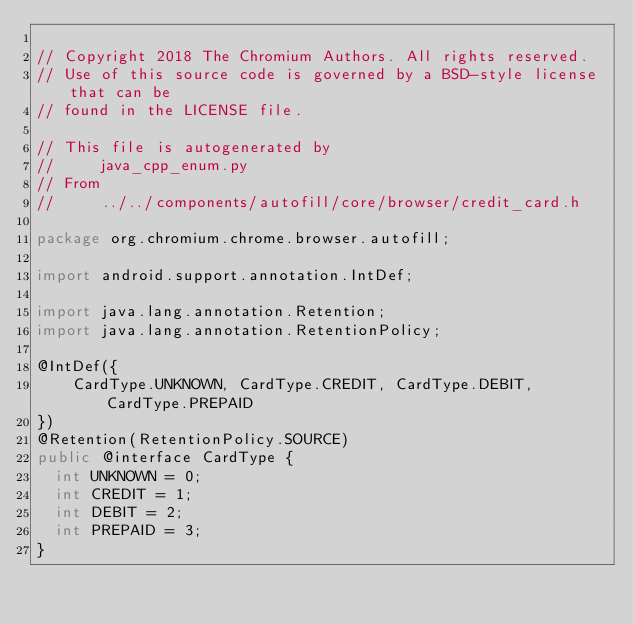<code> <loc_0><loc_0><loc_500><loc_500><_Java_>
// Copyright 2018 The Chromium Authors. All rights reserved.
// Use of this source code is governed by a BSD-style license that can be
// found in the LICENSE file.

// This file is autogenerated by
//     java_cpp_enum.py
// From
//     ../../components/autofill/core/browser/credit_card.h

package org.chromium.chrome.browser.autofill;

import android.support.annotation.IntDef;

import java.lang.annotation.Retention;
import java.lang.annotation.RetentionPolicy;

@IntDef({
    CardType.UNKNOWN, CardType.CREDIT, CardType.DEBIT, CardType.PREPAID
})
@Retention(RetentionPolicy.SOURCE)
public @interface CardType {
  int UNKNOWN = 0;
  int CREDIT = 1;
  int DEBIT = 2;
  int PREPAID = 3;
}
</code> 